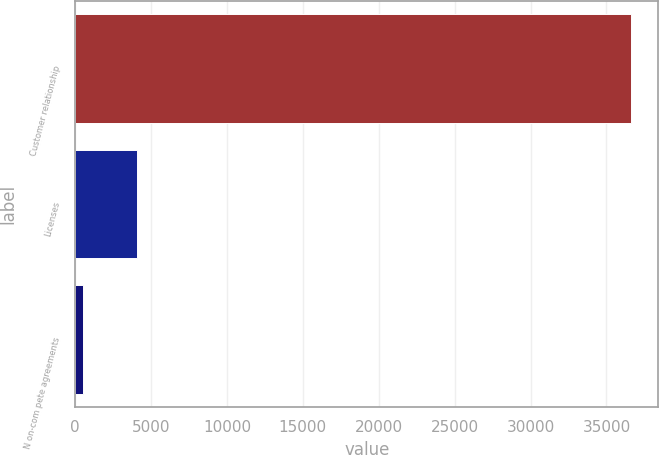Convert chart. <chart><loc_0><loc_0><loc_500><loc_500><bar_chart><fcel>Customer relationship<fcel>Licenses<fcel>N on-com pete agreements<nl><fcel>36593<fcel>4104.8<fcel>495<nl></chart> 